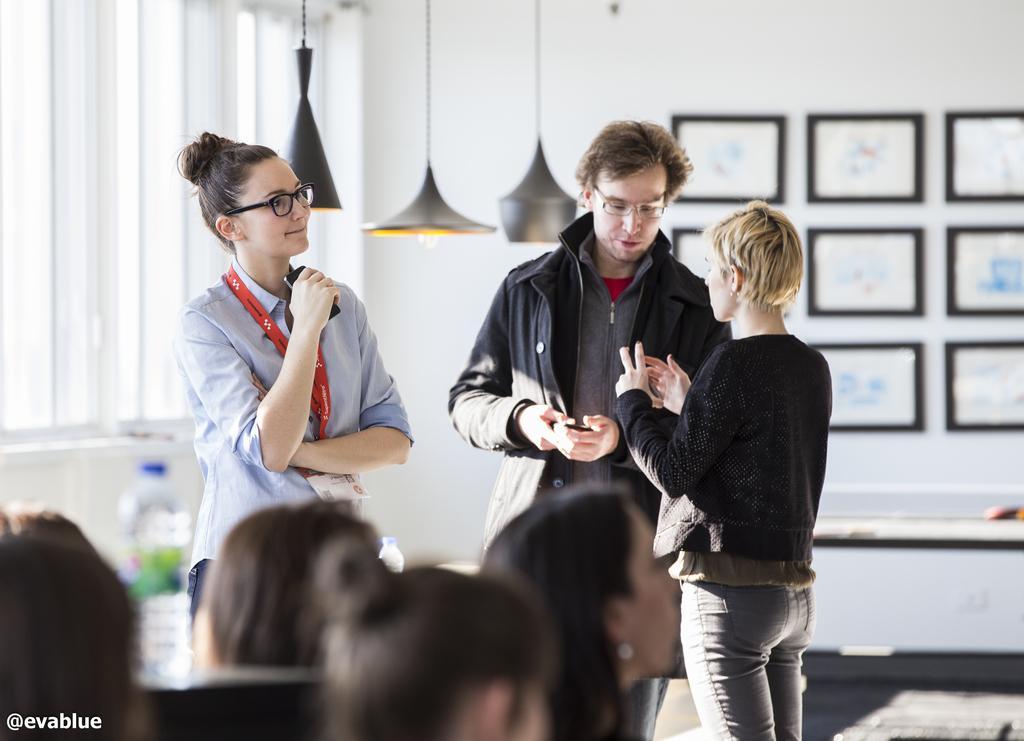In one or two sentences, can you explain what this image depicts? In this image, we can see three people are standing and holding black color objects. Here a woman and man are wearing glasses. Background we can see a wall, photo frames, windows, lights. At the bottom of the image, we can see few human heads, water bottle with sticker. Left side bottom corner, there is a watermark in the image. 